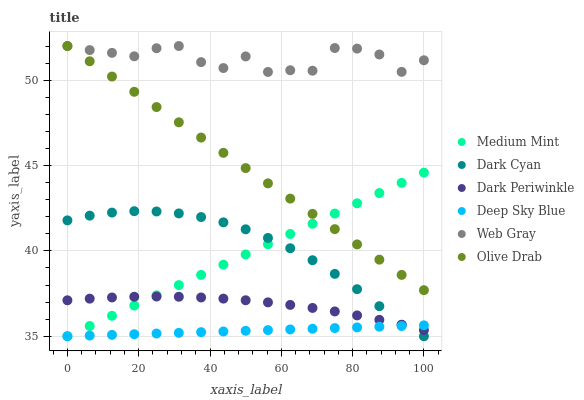Does Deep Sky Blue have the minimum area under the curve?
Answer yes or no. Yes. Does Web Gray have the maximum area under the curve?
Answer yes or no. Yes. Does Web Gray have the minimum area under the curve?
Answer yes or no. No. Does Deep Sky Blue have the maximum area under the curve?
Answer yes or no. No. Is Medium Mint the smoothest?
Answer yes or no. Yes. Is Web Gray the roughest?
Answer yes or no. Yes. Is Deep Sky Blue the smoothest?
Answer yes or no. No. Is Deep Sky Blue the roughest?
Answer yes or no. No. Does Medium Mint have the lowest value?
Answer yes or no. Yes. Does Web Gray have the lowest value?
Answer yes or no. No. Does Olive Drab have the highest value?
Answer yes or no. Yes. Does Deep Sky Blue have the highest value?
Answer yes or no. No. Is Medium Mint less than Web Gray?
Answer yes or no. Yes. Is Web Gray greater than Dark Periwinkle?
Answer yes or no. Yes. Does Deep Sky Blue intersect Dark Cyan?
Answer yes or no. Yes. Is Deep Sky Blue less than Dark Cyan?
Answer yes or no. No. Is Deep Sky Blue greater than Dark Cyan?
Answer yes or no. No. Does Medium Mint intersect Web Gray?
Answer yes or no. No. 